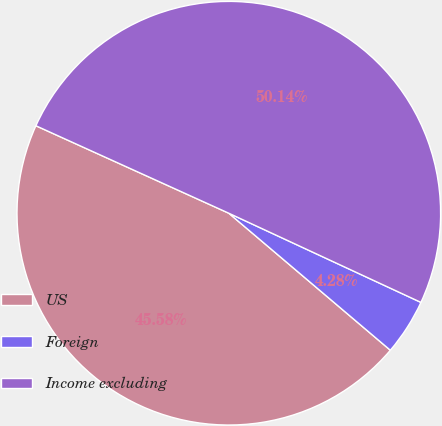Convert chart to OTSL. <chart><loc_0><loc_0><loc_500><loc_500><pie_chart><fcel>US<fcel>Foreign<fcel>Income excluding<nl><fcel>45.58%<fcel>4.28%<fcel>50.14%<nl></chart> 